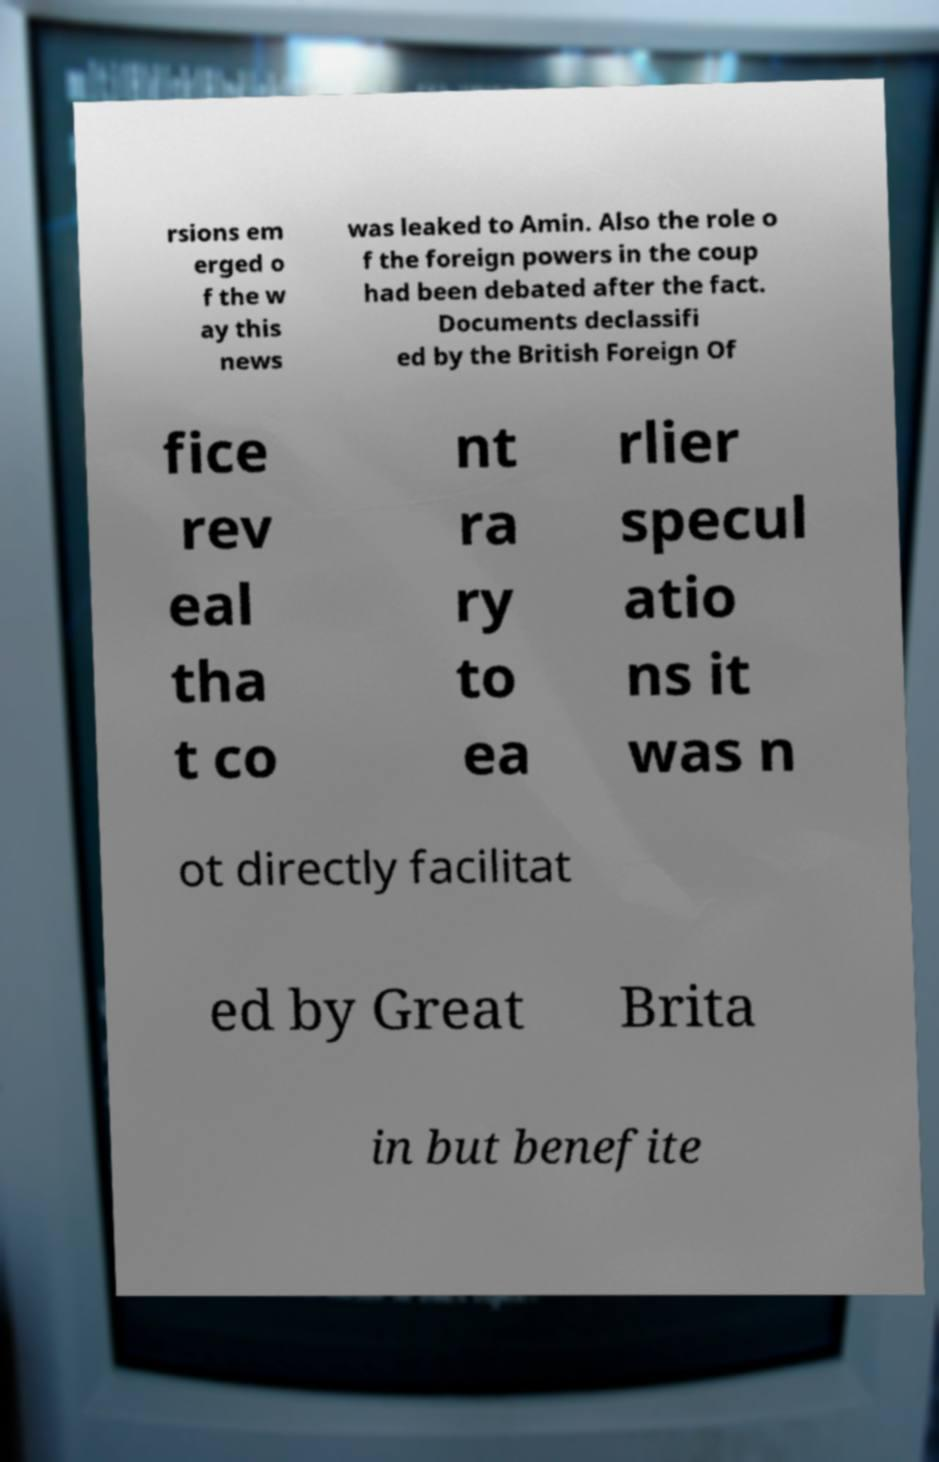Could you assist in decoding the text presented in this image and type it out clearly? rsions em erged o f the w ay this news was leaked to Amin. Also the role o f the foreign powers in the coup had been debated after the fact. Documents declassifi ed by the British Foreign Of fice rev eal tha t co nt ra ry to ea rlier specul atio ns it was n ot directly facilitat ed by Great Brita in but benefite 